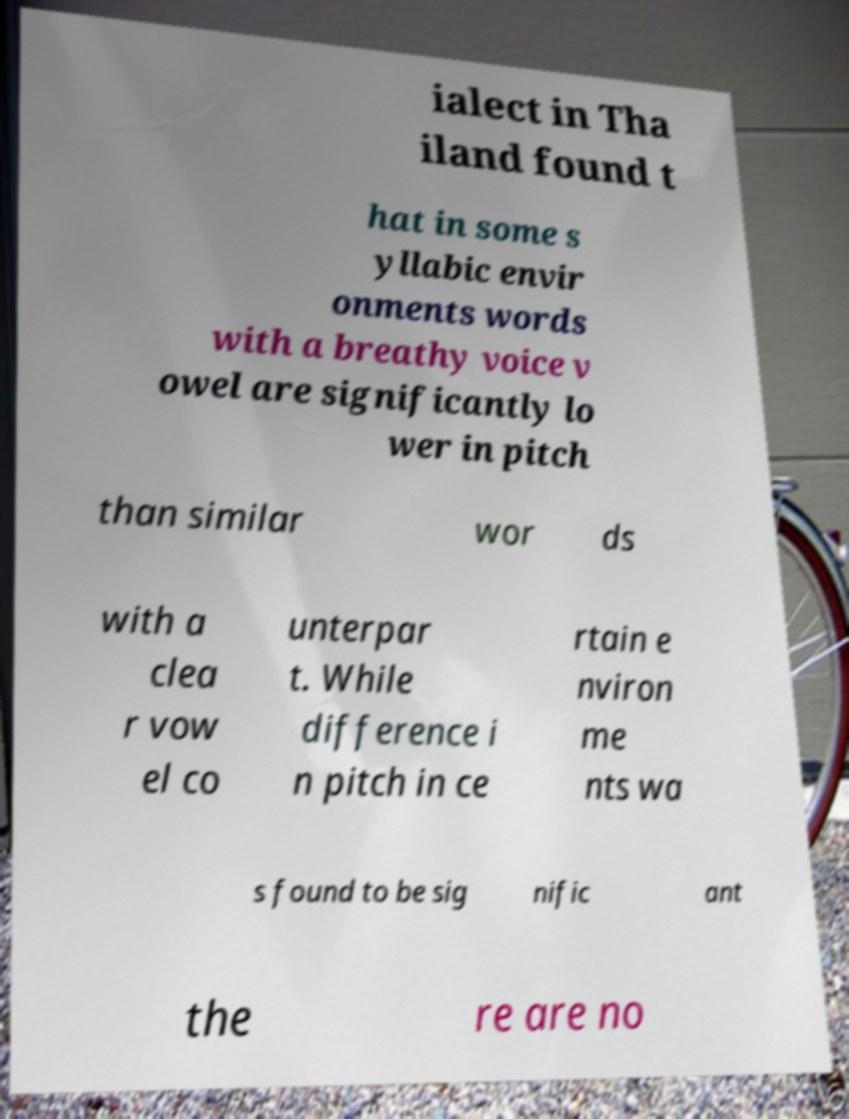What messages or text are displayed in this image? I need them in a readable, typed format. ialect in Tha iland found t hat in some s yllabic envir onments words with a breathy voice v owel are significantly lo wer in pitch than similar wor ds with a clea r vow el co unterpar t. While difference i n pitch in ce rtain e nviron me nts wa s found to be sig nific ant the re are no 